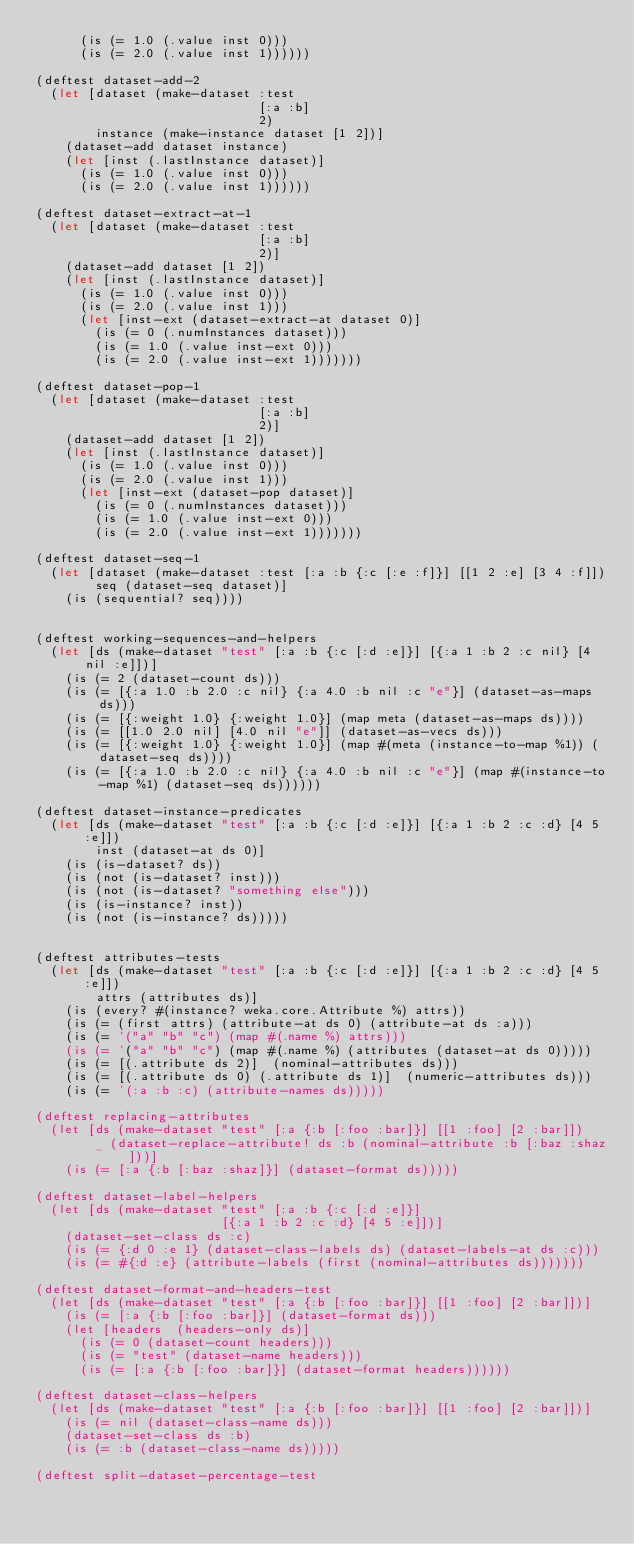<code> <loc_0><loc_0><loc_500><loc_500><_Clojure_>      (is (= 1.0 (.value inst 0)))
      (is (= 2.0 (.value inst 1))))))

(deftest dataset-add-2
  (let [dataset (make-dataset :test
                              [:a :b]
                              2)
        instance (make-instance dataset [1 2])]
    (dataset-add dataset instance)
    (let [inst (.lastInstance dataset)]
      (is (= 1.0 (.value inst 0)))
      (is (= 2.0 (.value inst 1))))))

(deftest dataset-extract-at-1
  (let [dataset (make-dataset :test
                              [:a :b]
                              2)]
    (dataset-add dataset [1 2])
    (let [inst (.lastInstance dataset)]
      (is (= 1.0 (.value inst 0)))
      (is (= 2.0 (.value inst 1)))
      (let [inst-ext (dataset-extract-at dataset 0)]
        (is (= 0 (.numInstances dataset)))
        (is (= 1.0 (.value inst-ext 0)))
        (is (= 2.0 (.value inst-ext 1)))))))

(deftest dataset-pop-1
  (let [dataset (make-dataset :test
                              [:a :b]
                              2)]
    (dataset-add dataset [1 2])
    (let [inst (.lastInstance dataset)]
      (is (= 1.0 (.value inst 0)))
      (is (= 2.0 (.value inst 1)))
      (let [inst-ext (dataset-pop dataset)]
        (is (= 0 (.numInstances dataset)))
        (is (= 1.0 (.value inst-ext 0)))
        (is (= 2.0 (.value inst-ext 1)))))))

(deftest dataset-seq-1
  (let [dataset (make-dataset :test [:a :b {:c [:e :f]}] [[1 2 :e] [3 4 :f]])
        seq (dataset-seq dataset)]
    (is (sequential? seq))))


(deftest working-sequences-and-helpers
  (let [ds (make-dataset "test" [:a :b {:c [:d :e]}] [{:a 1 :b 2 :c nil} [4 nil :e]])]
    (is (= 2 (dataset-count ds)))
    (is (= [{:a 1.0 :b 2.0 :c nil} {:a 4.0 :b nil :c "e"}] (dataset-as-maps ds)))
    (is (= [{:weight 1.0} {:weight 1.0}] (map meta (dataset-as-maps ds))))
    (is (= [[1.0 2.0 nil] [4.0 nil "e"]] (dataset-as-vecs ds)))
    (is (= [{:weight 1.0} {:weight 1.0}] (map #(meta (instance-to-map %1)) (dataset-seq ds))))
    (is (= [{:a 1.0 :b 2.0 :c nil} {:a 4.0 :b nil :c "e"}] (map #(instance-to-map %1) (dataset-seq ds))))))

(deftest dataset-instance-predicates
  (let [ds (make-dataset "test" [:a :b {:c [:d :e]}] [{:a 1 :b 2 :c :d} [4 5 :e]])
        inst (dataset-at ds 0)]
    (is (is-dataset? ds))
    (is (not (is-dataset? inst)))
    (is (not (is-dataset? "something else")))
    (is (is-instance? inst))
    (is (not (is-instance? ds)))))


(deftest attributes-tests
  (let [ds (make-dataset "test" [:a :b {:c [:d :e]}] [{:a 1 :b 2 :c :d} [4 5 :e]])
        attrs (attributes ds)]
    (is (every? #(instance? weka.core.Attribute %) attrs))
    (is (= (first attrs) (attribute-at ds 0) (attribute-at ds :a)))
    (is (= '("a" "b" "c") (map #(.name %) attrs)))
    (is (= '("a" "b" "c") (map #(.name %) (attributes (dataset-at ds 0)))))
    (is (= [(.attribute ds 2)]  (nominal-attributes ds)))
    (is (= [(.attribute ds 0) (.attribute ds 1)]  (numeric-attributes ds)))
    (is (= '(:a :b :c) (attribute-names ds)))))

(deftest replacing-attributes
  (let [ds (make-dataset "test" [:a {:b [:foo :bar]}] [[1 :foo] [2 :bar]])
        _ (dataset-replace-attribute! ds :b (nominal-attribute :b [:baz :shaz]))]
    (is (= [:a {:b [:baz :shaz]}] (dataset-format ds)))))

(deftest dataset-label-helpers
  (let [ds (make-dataset "test" [:a :b {:c [:d :e]}]
                         [{:a 1 :b 2 :c :d} [4 5 :e]])]
    (dataset-set-class ds :c)
    (is (= {:d 0 :e 1} (dataset-class-labels ds) (dataset-labels-at ds :c)))
    (is (= #{:d :e} (attribute-labels (first (nominal-attributes ds)))))))

(deftest dataset-format-and-headers-test
  (let [ds (make-dataset "test" [:a {:b [:foo :bar]}] [[1 :foo] [2 :bar]])]
    (is (= [:a {:b [:foo :bar]}] (dataset-format ds)))
    (let [headers  (headers-only ds)]
      (is (= 0 (dataset-count headers)))
      (is (= "test" (dataset-name headers)))
      (is (= [:a {:b [:foo :bar]}] (dataset-format headers))))))

(deftest dataset-class-helpers
  (let [ds (make-dataset "test" [:a {:b [:foo :bar]}] [[1 :foo] [2 :bar]])]
    (is (= nil (dataset-class-name ds)))
    (dataset-set-class ds :b)
    (is (= :b (dataset-class-name ds)))))

(deftest split-dataset-percentage-test</code> 